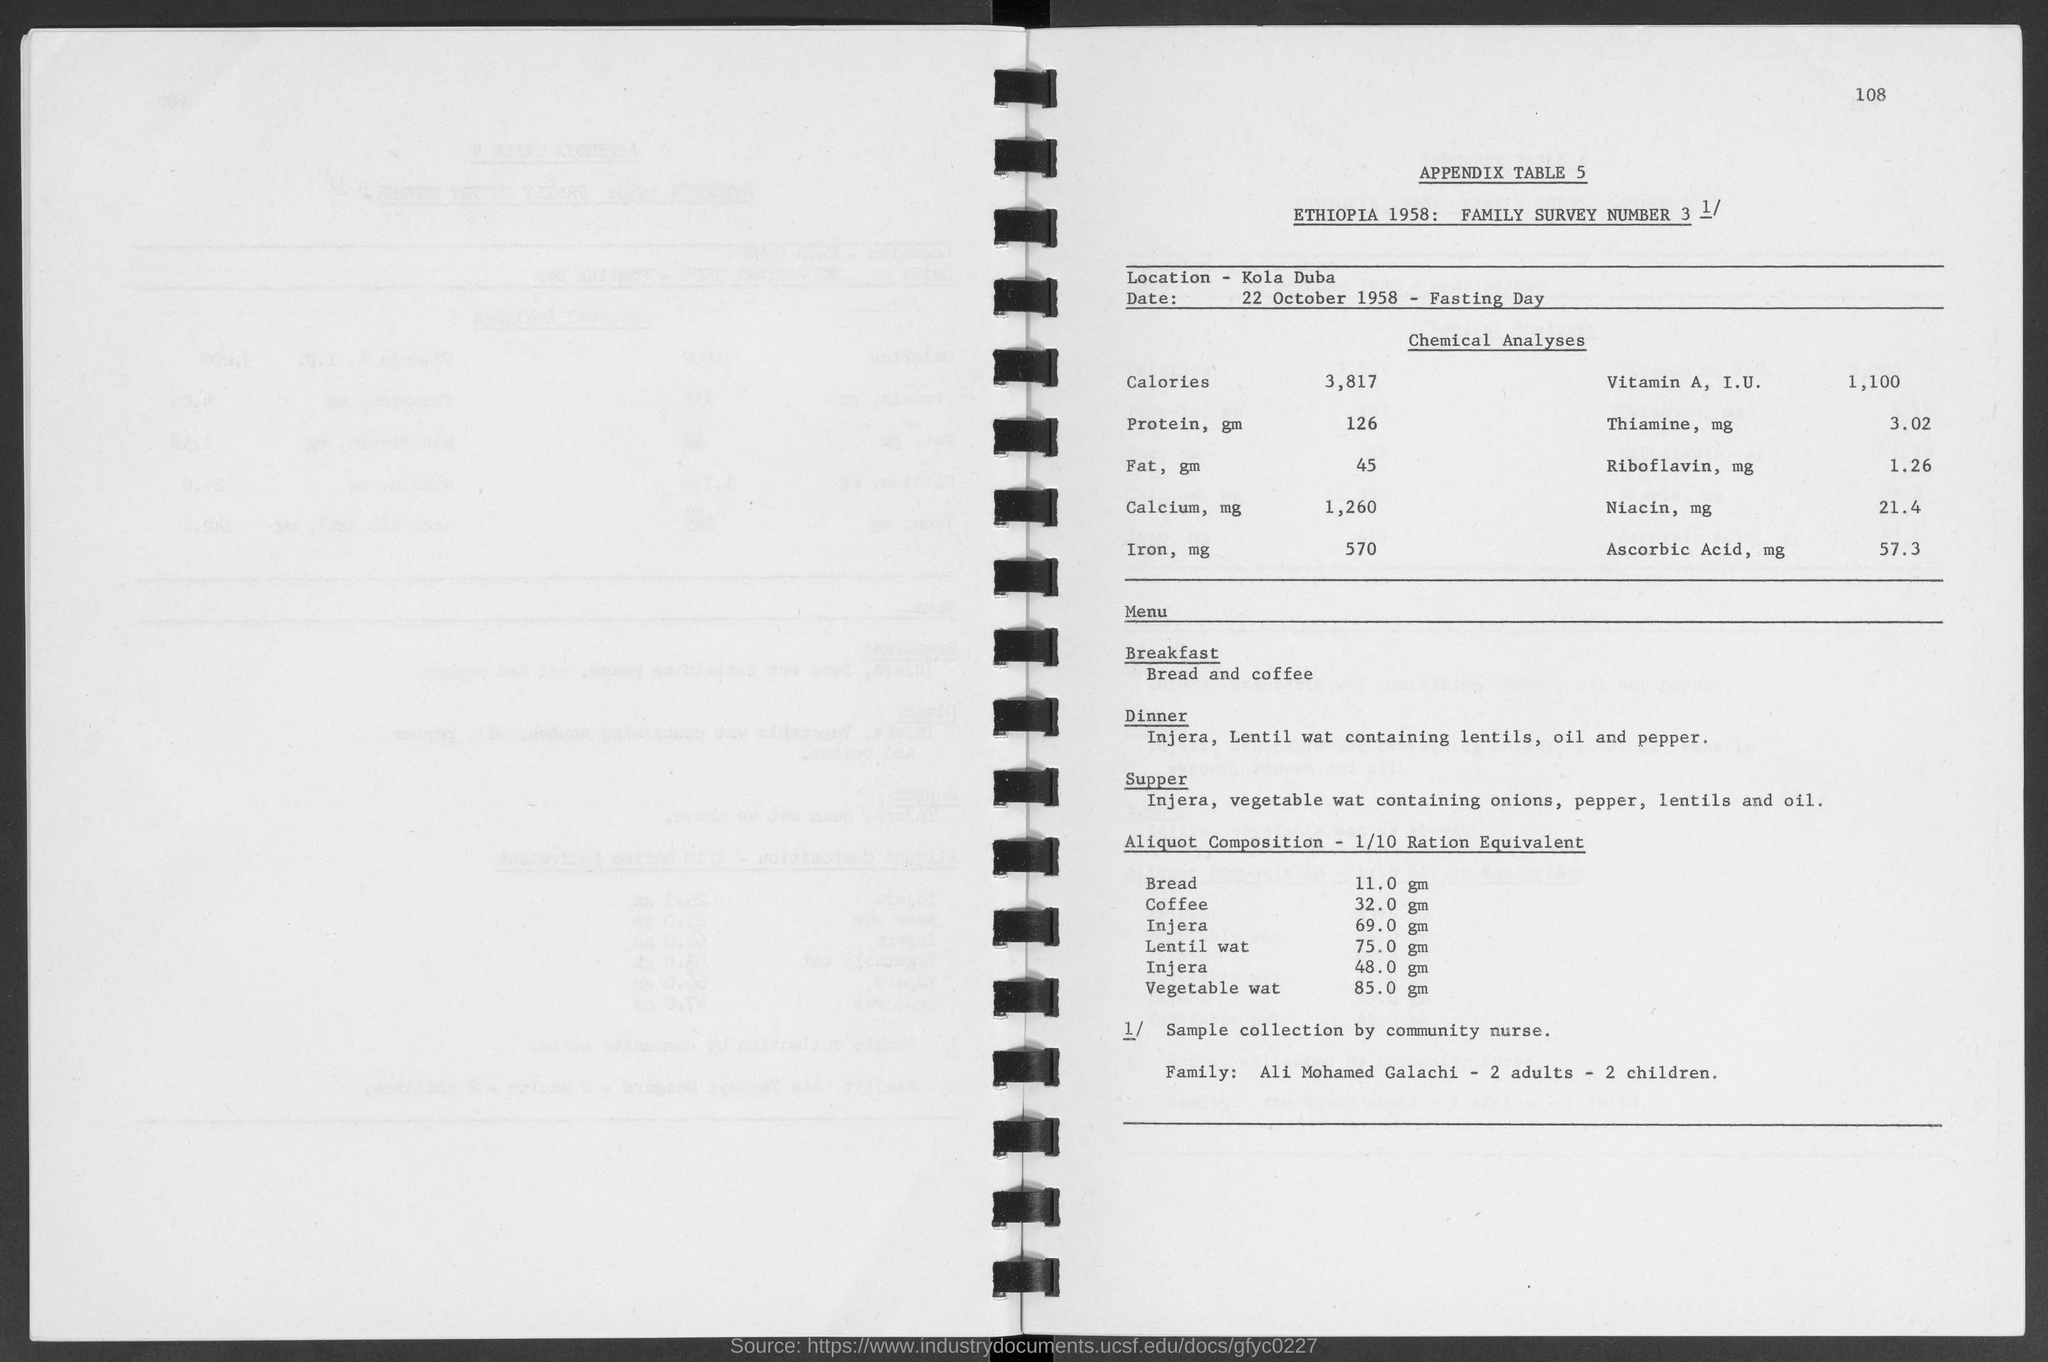What is the number at top-right corner of the page?
Your answer should be very brief. 108. What is the location ?
Make the answer very short. Kola duba. When is the date for fasting day ?
Give a very brief answer. 22 October 1958. 